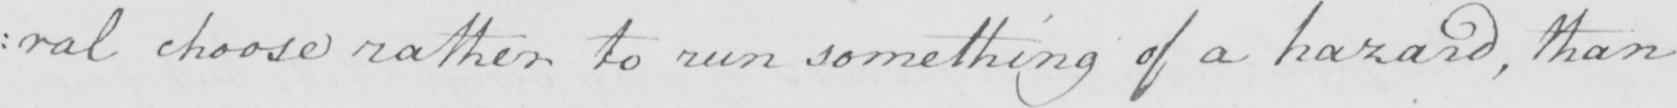Can you read and transcribe this handwriting? : ral choose rather to run something of a hazard , than 